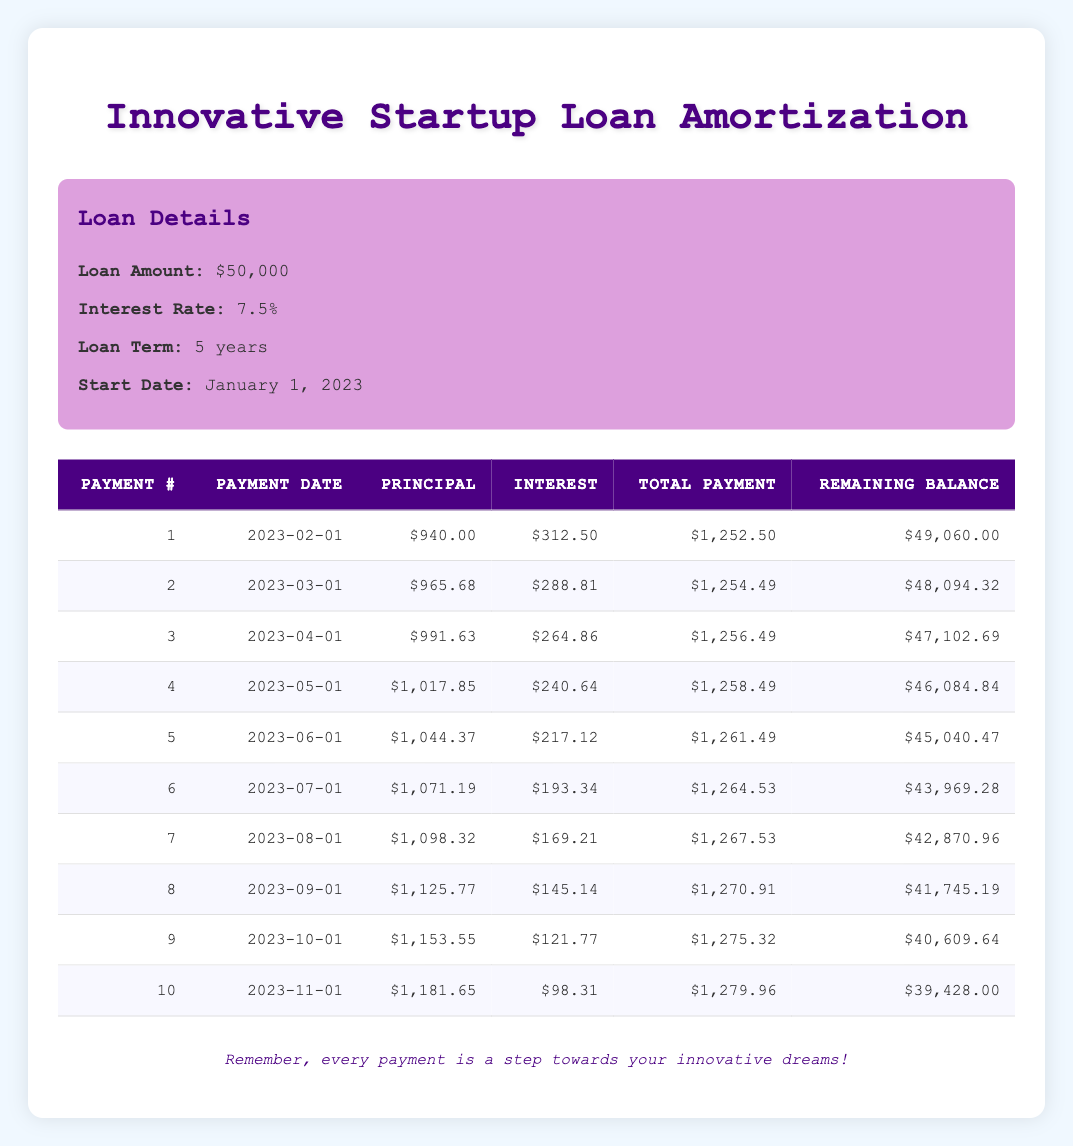What is the total amount paid in the first three payments? To calculate the total amount paid in the first three payments, we look at the total payments for payment numbers 1, 2, and 3: $1,252.50 + $1,254.49 + $1,256.49 = $3,763.48
Answer: $3,763.48 What is the principal payment amount for the 5th payment? In the 5th row of the table, the principal payment is specified as $1,044.37
Answer: $1,044.37 Is the interest payment for the 6th payment greater than the principal payment for the 5th payment? The interest payment for the 6th payment is $193.34 and the principal payment for the 5th payment is $1,044.37. Since $193.34 is less than $1,044.37, the statement is false
Answer: No What is the remaining balance after the 8th payment? The remaining balance for the 8th payment, as shown in the table, is $41,745.19
Answer: $41,745.19 What is the average total payment for the first ten payments? To find the average total payment, we first sum the total payments for all ten payments: $1,252.50 + $1,254.49 + $1,256.49 + $1,258.49 + $1,261.49 + $1,264.53 + $1,267.53 + $1,270.91 + $1,275.32 + $1,279.96 = $12,730.18. There are 10 payments, so the average is $12,730.18 / 10 = $1,273.02
Answer: $1,273.02 How much did the remaining balance decrease from the 1st payment to the 10th payment? The remaining balance after the 1st payment is $49,060.00 and after the 10th payment is $39,428.00. To find the decrease, we subtract: $49,060.00 - $39,428.00 = $9,632.00
Answer: $9,632.00 What was the total interest paid in the first four payments? The total interest paid in the first four payments can be calculated by summing the interest payments for payments 1 to 4: $312.50 + $288.81 + $264.86 + $240.64 = $1,106.81
Answer: $1,106.81 Is the total payment for the 7th payment more than $1,270? The total payment for the 7th payment is $1,267.53, which is less than $1,270. Hence, the statement is false
Answer: No What is the change in principal payment from the 2nd payment to the 4th payment? The principal payment for the 2nd payment is $965.68 and for the 4th payment is $1,017.85. The change is calculated as $1,017.85 - $965.68 = $52.17
Answer: $52.17 